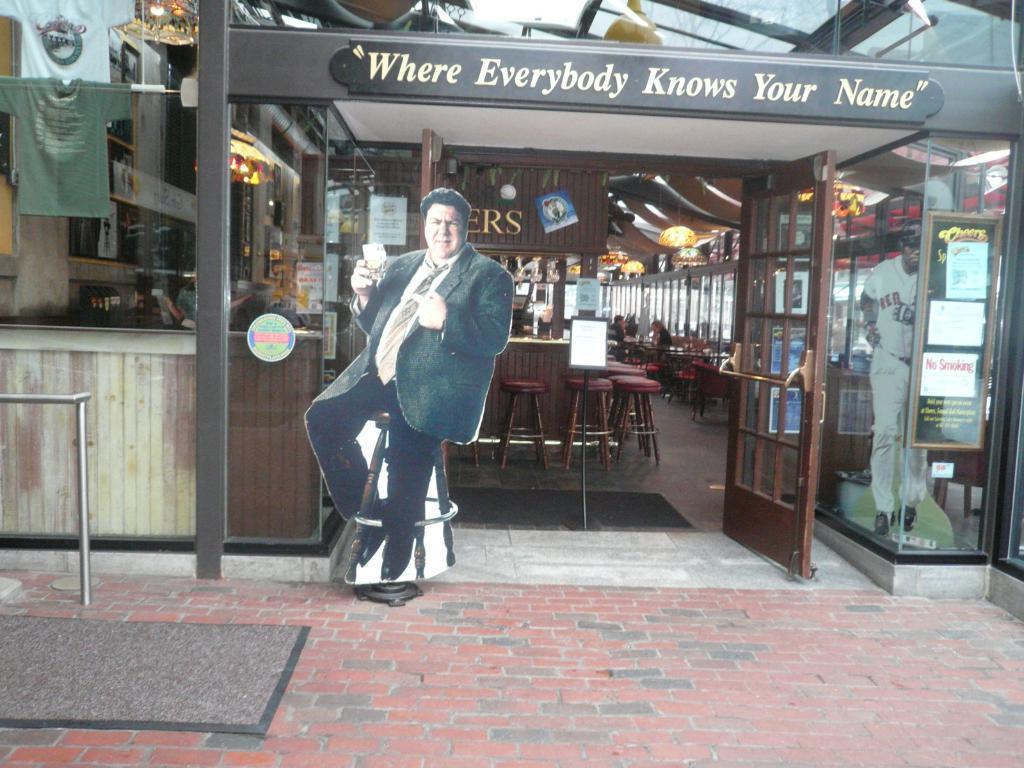In one or two sentences, can you explain what this image depicts? In this image we can see board, glass objects, posters, door and other objects. In the background of the image there are chairs, name board, lights, posters, people, glass windows and other objects. At the bottom of the image there is a floor and a floor mat. At the top of the image there are glass objects and other objects. 